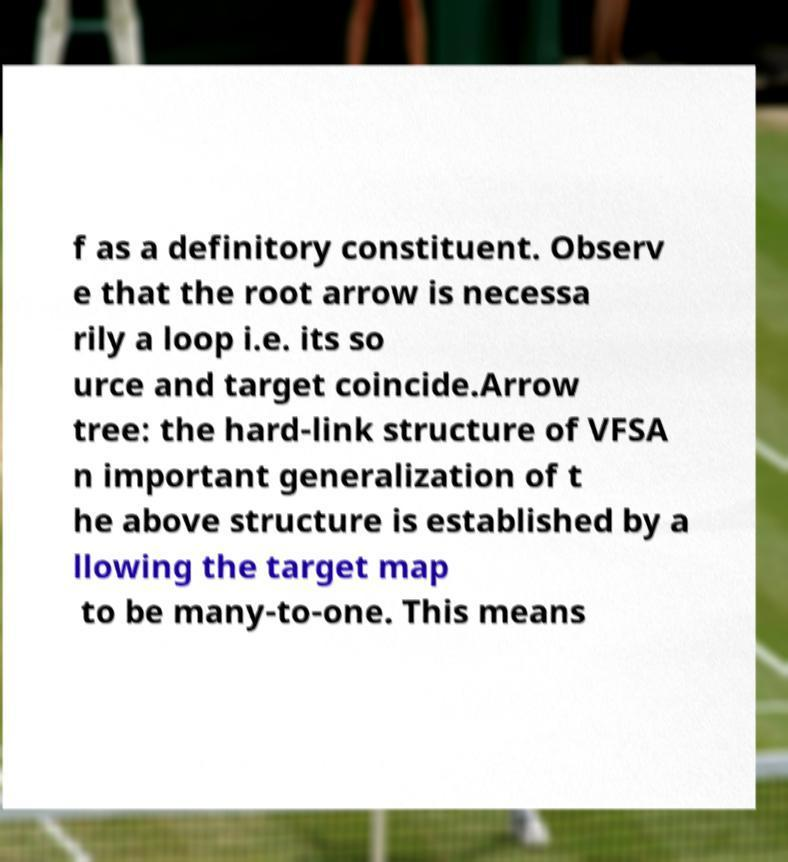I need the written content from this picture converted into text. Can you do that? f as a definitory constituent. Observ e that the root arrow is necessa rily a loop i.e. its so urce and target coincide.Arrow tree: the hard-link structure of VFSA n important generalization of t he above structure is established by a llowing the target map to be many-to-one. This means 